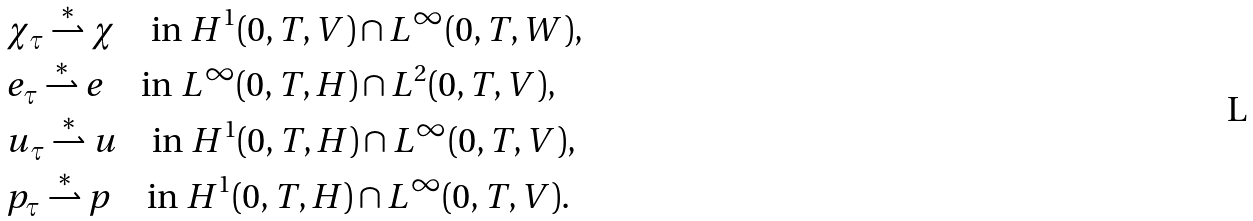Convert formula to latex. <formula><loc_0><loc_0><loc_500><loc_500>& \chi _ { \tau } \stackrel { \ast } { \rightharpoonup } \chi \quad \text {in } H ^ { 1 } ( 0 , T , V ) \cap L ^ { \infty } ( 0 , T , W ) , \\ & e _ { \tau } \stackrel { \ast } { \rightharpoonup } e \quad \text {in } L ^ { \infty } ( 0 , T , H ) \cap L ^ { 2 } ( 0 , T , V ) , \\ & u _ { \tau } \stackrel { \ast } { \rightharpoonup } u \quad \text {in } H ^ { 1 } ( 0 , T , H ) \cap L ^ { \infty } ( 0 , T , V ) , \\ & p _ { \tau } \stackrel { \ast } { \rightharpoonup } p \quad \text {in } H ^ { 1 } ( 0 , T , H ) \cap L ^ { \infty } ( 0 , T , V ) .</formula> 